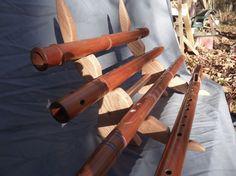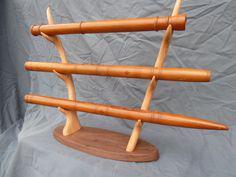The first image is the image on the left, the second image is the image on the right. Assess this claim about the two images: "There are more instruments in the image on the right.". Correct or not? Answer yes or no. No. The first image is the image on the left, the second image is the image on the right. Examine the images to the left and right. Is the description "Each image features a wooden holder that displays flutes horizontally, and one of the flute holders stands upright on an oval base." accurate? Answer yes or no. Yes. 